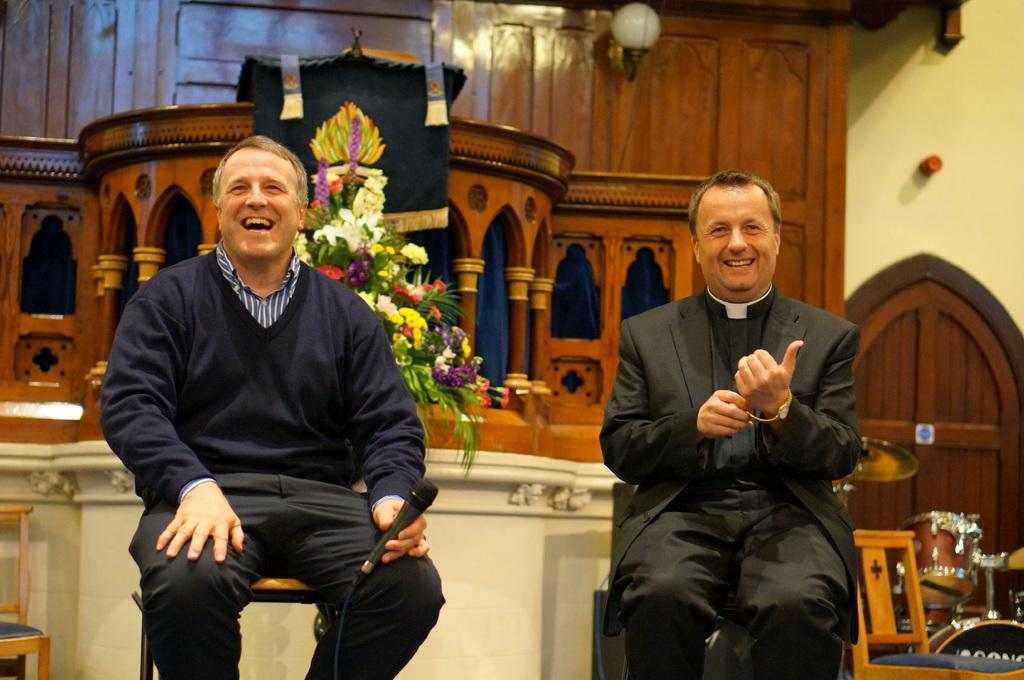How many men are present in the image? There are two men in the image. What are the men doing in the image? The men are sitting on chairs and holding microphones. What can be seen in the background of the image? There is a wall, a light, a flower bouquet, at least one musical instrument, and additional chairs in the background of the image. What direction is the thunder coming from in the image? There is no thunder present in the image, so it is not possible to determine the direction from which it might be coming. 